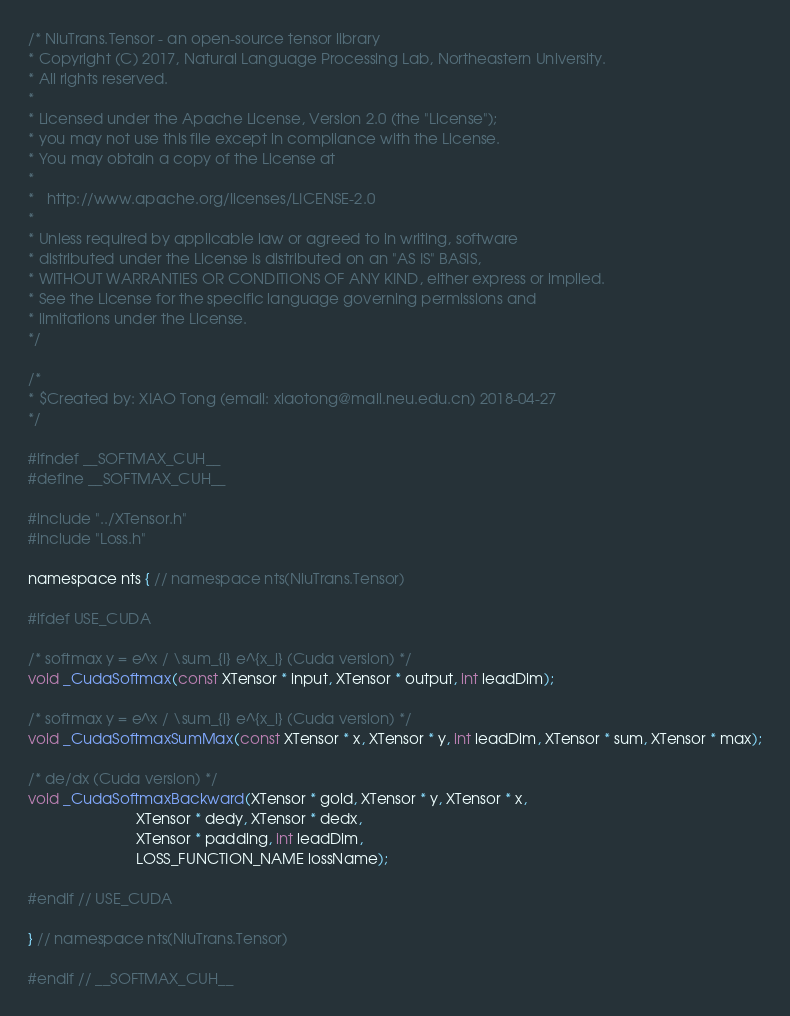<code> <loc_0><loc_0><loc_500><loc_500><_Cuda_>/* NiuTrans.Tensor - an open-source tensor library
* Copyright (C) 2017, Natural Language Processing Lab, Northeastern University.
* All rights reserved.
*
* Licensed under the Apache License, Version 2.0 (the "License");
* you may not use this file except in compliance with the License.
* You may obtain a copy of the License at
*
*   http://www.apache.org/licenses/LICENSE-2.0
*
* Unless required by applicable law or agreed to in writing, software
* distributed under the License is distributed on an "AS IS" BASIS,
* WITHOUT WARRANTIES OR CONDITIONS OF ANY KIND, either express or implied.
* See the License for the specific language governing permissions and
* limitations under the License.
*/

/*
* $Created by: XIAO Tong (email: xiaotong@mail.neu.edu.cn) 2018-04-27
*/

#ifndef __SOFTMAX_CUH__
#define __SOFTMAX_CUH__

#include "../XTensor.h"
#include "Loss.h"

namespace nts { // namespace nts(NiuTrans.Tensor)

#ifdef USE_CUDA

/* softmax y = e^x / \sum_{i} e^{x_i} (Cuda version) */
void _CudaSoftmax(const XTensor * input, XTensor * output, int leadDim);

/* softmax y = e^x / \sum_{i} e^{x_i} (Cuda version) */
void _CudaSoftmaxSumMax(const XTensor * x, XTensor * y, int leadDim, XTensor * sum, XTensor * max);

/* de/dx (Cuda version) */
void _CudaSoftmaxBackward(XTensor * gold, XTensor * y, XTensor * x,
                          XTensor * dedy, XTensor * dedx, 
                          XTensor * padding, int leadDim, 
                          LOSS_FUNCTION_NAME lossName);

#endif // USE_CUDA

} // namespace nts(NiuTrans.Tensor)

#endif // __SOFTMAX_CUH__</code> 